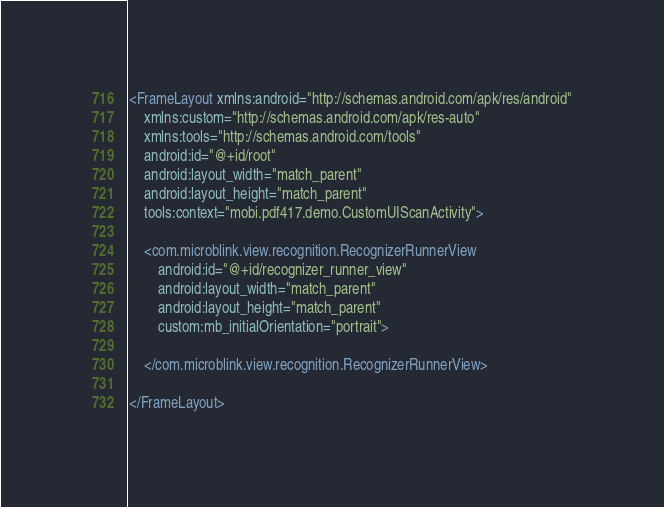Convert code to text. <code><loc_0><loc_0><loc_500><loc_500><_XML_><FrameLayout xmlns:android="http://schemas.android.com/apk/res/android"
    xmlns:custom="http://schemas.android.com/apk/res-auto"
    xmlns:tools="http://schemas.android.com/tools"
    android:id="@+id/root"
    android:layout_width="match_parent"
    android:layout_height="match_parent"
    tools:context="mobi.pdf417.demo.CustomUIScanActivity">

    <com.microblink.view.recognition.RecognizerRunnerView
        android:id="@+id/recognizer_runner_view"
        android:layout_width="match_parent"
        android:layout_height="match_parent"
        custom:mb_initialOrientation="portrait">

    </com.microblink.view.recognition.RecognizerRunnerView>

</FrameLayout>
</code> 